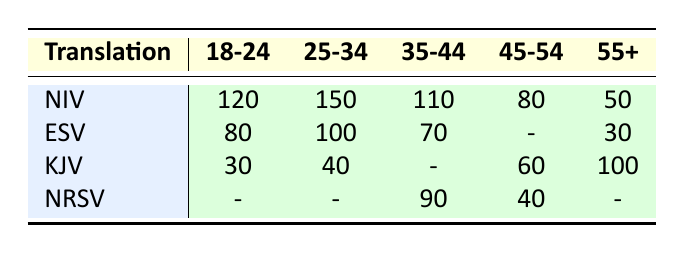What is the highest preference count for the New International Version (NIV)? The highest preference count for NIV can be found by looking at the values in the NIV row. The maximum count across all age groups is 150, which is in the 25-34 age group.
Answer: 150 Which translation has the most significant preference among 45-54 year-olds? To determine this, we look at the values in the 45-54 column. The King James Version (KJV) has the highest count of 60 compared to other translations in that age group.
Answer: King James Version (KJV) What is the total preference count for the English Standard Version (ESV) across all age groups? The total preference count for ESV can be calculated by adding the values from its column: 80 (18-24) + 100 (25-34) + 70 (35-44) + 0 (45-54) + 30 (55+) = 380.
Answer: 380 Is the preference for King James Version (KJV) higher among 55+ year-olds than among 25-34 year-olds? The preference count for KJV in the 55+ year group is 100, whereas for the 25-34 year group, it is 40. Since 100 is greater than 40, the statement is true.
Answer: Yes What percentage of 35-44 year-olds prefer the New Revised Standard Version (NRSV) compared to the total preference count for that age group? The total preference count for age group 35-44 is 90 (NRSV) + 110 (NIV) + 70 (ESV) = 270. The percentage for NRSV is (90 / 270) * 100 = 33.33%.
Answer: 33.33% Which translation has the lowest preference count among those aged 18-24? In the 18-24 age group, the translation with the lowest preference count is KJV, with a count of 30, compared to NIV (120) and ESV (80).
Answer: King James Version (KJV) What is the combined preference count for translations among 45-54 year-olds? We add the preference counts for that age group based on the table: KJV (60) + NIV (80) + NRSV (40) = 180.
Answer: 180 How many more people prefer the English Standard Version (ESV) in the 25-34 age group compared to the 55+ age group? The preference count for ESV in the 25-34 age group is 100, while in the 55+ age group, it is 30. The difference is 100 - 30 = 70.
Answer: 70 